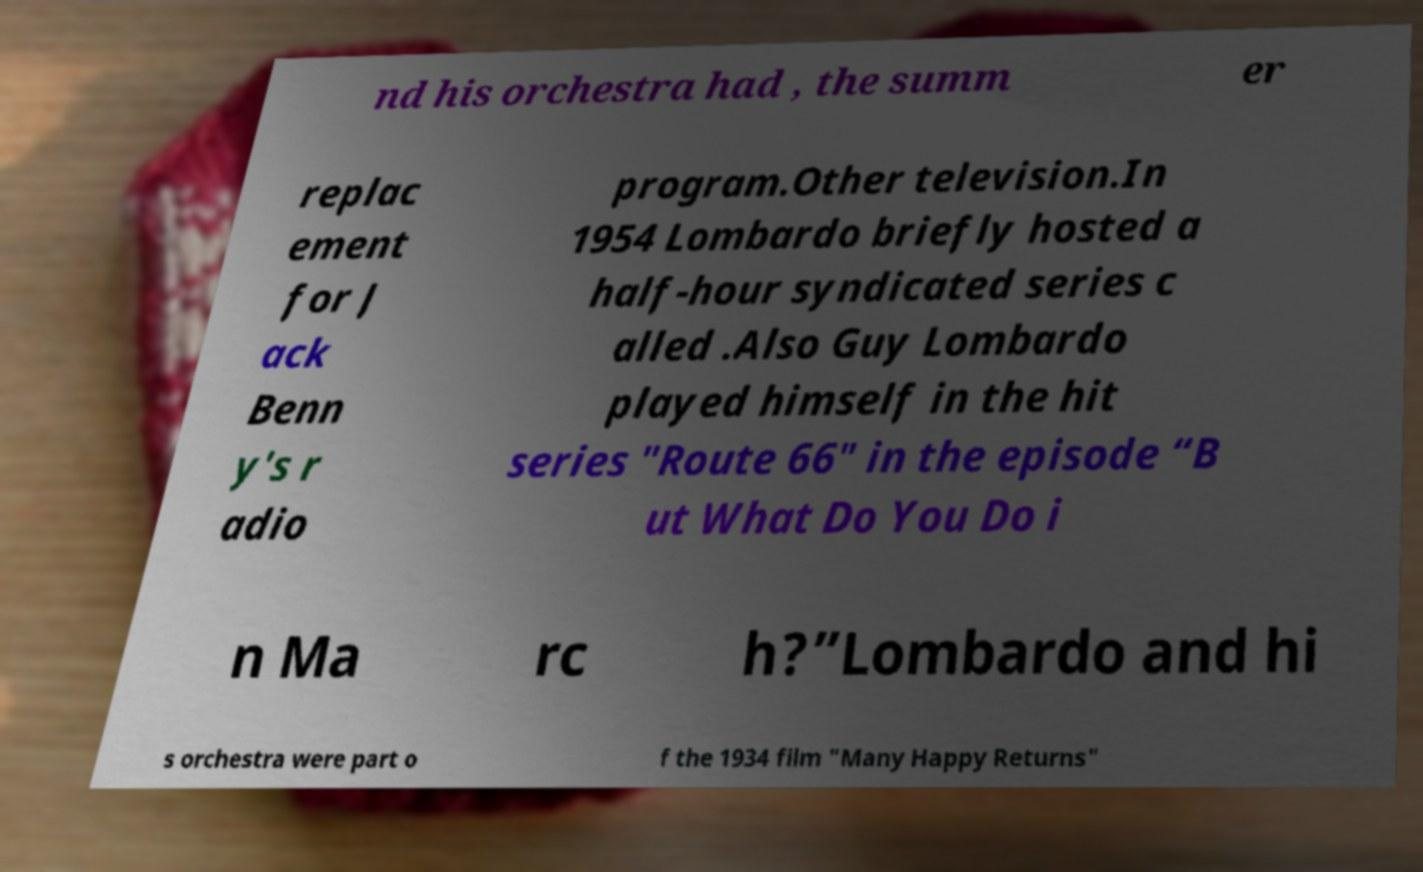For documentation purposes, I need the text within this image transcribed. Could you provide that? nd his orchestra had , the summ er replac ement for J ack Benn y's r adio program.Other television.In 1954 Lombardo briefly hosted a half-hour syndicated series c alled .Also Guy Lombardo played himself in the hit series "Route 66" in the episode “B ut What Do You Do i n Ma rc h?”Lombardo and hi s orchestra were part o f the 1934 film "Many Happy Returns" 